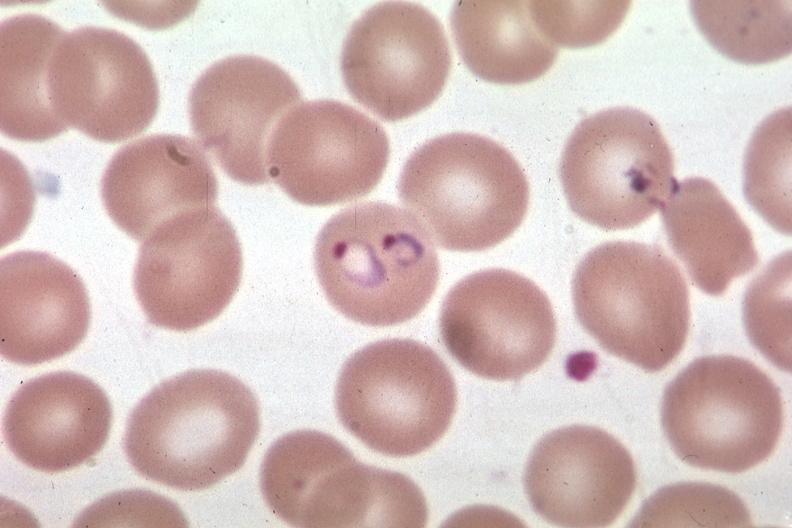does hemorrhagic corpus luteum show oil wrights excellent?
Answer the question using a single word or phrase. No 